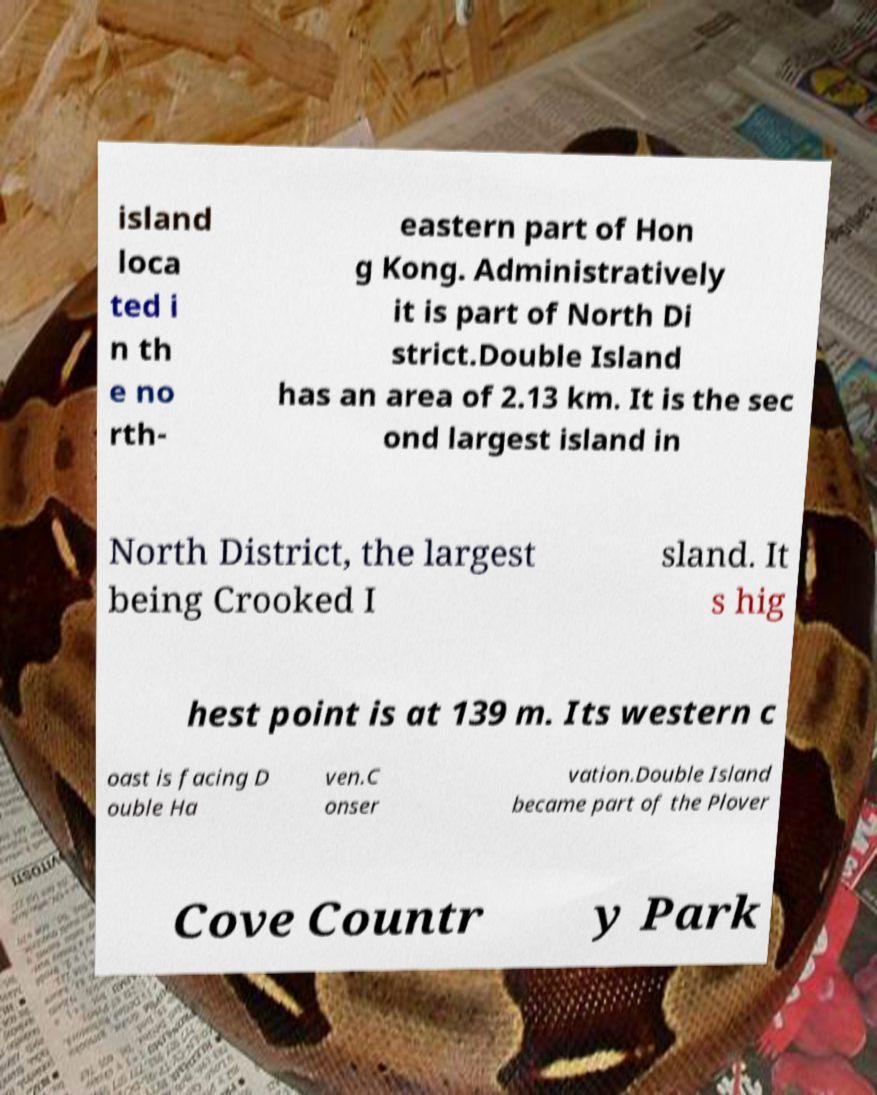Can you accurately transcribe the text from the provided image for me? island loca ted i n th e no rth- eastern part of Hon g Kong. Administratively it is part of North Di strict.Double Island has an area of 2.13 km. It is the sec ond largest island in North District, the largest being Crooked I sland. It s hig hest point is at 139 m. Its western c oast is facing D ouble Ha ven.C onser vation.Double Island became part of the Plover Cove Countr y Park 